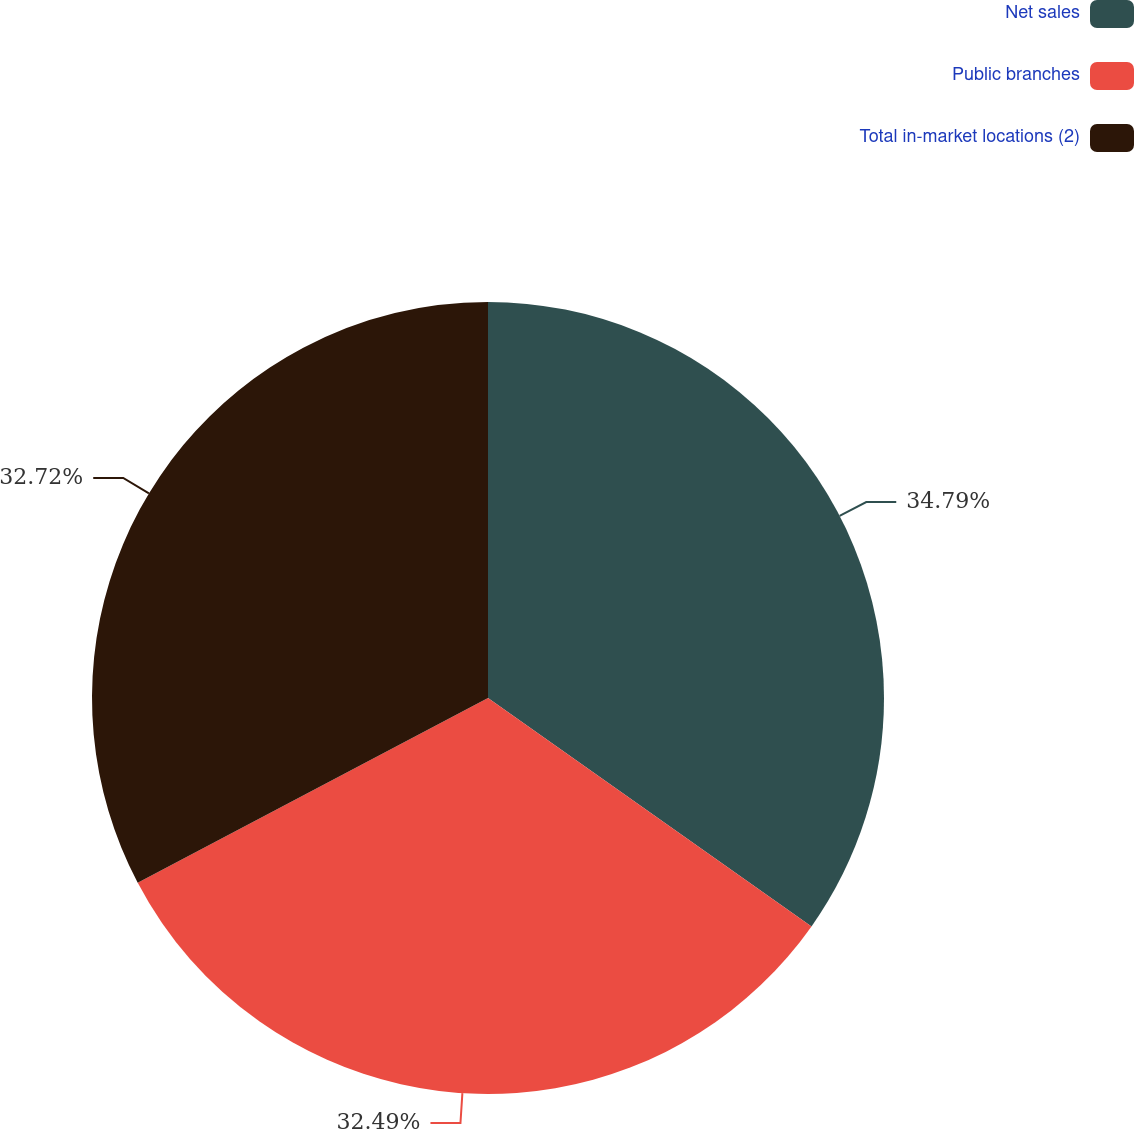Convert chart. <chart><loc_0><loc_0><loc_500><loc_500><pie_chart><fcel>Net sales<fcel>Public branches<fcel>Total in-market locations (2)<nl><fcel>34.78%<fcel>32.49%<fcel>32.72%<nl></chart> 